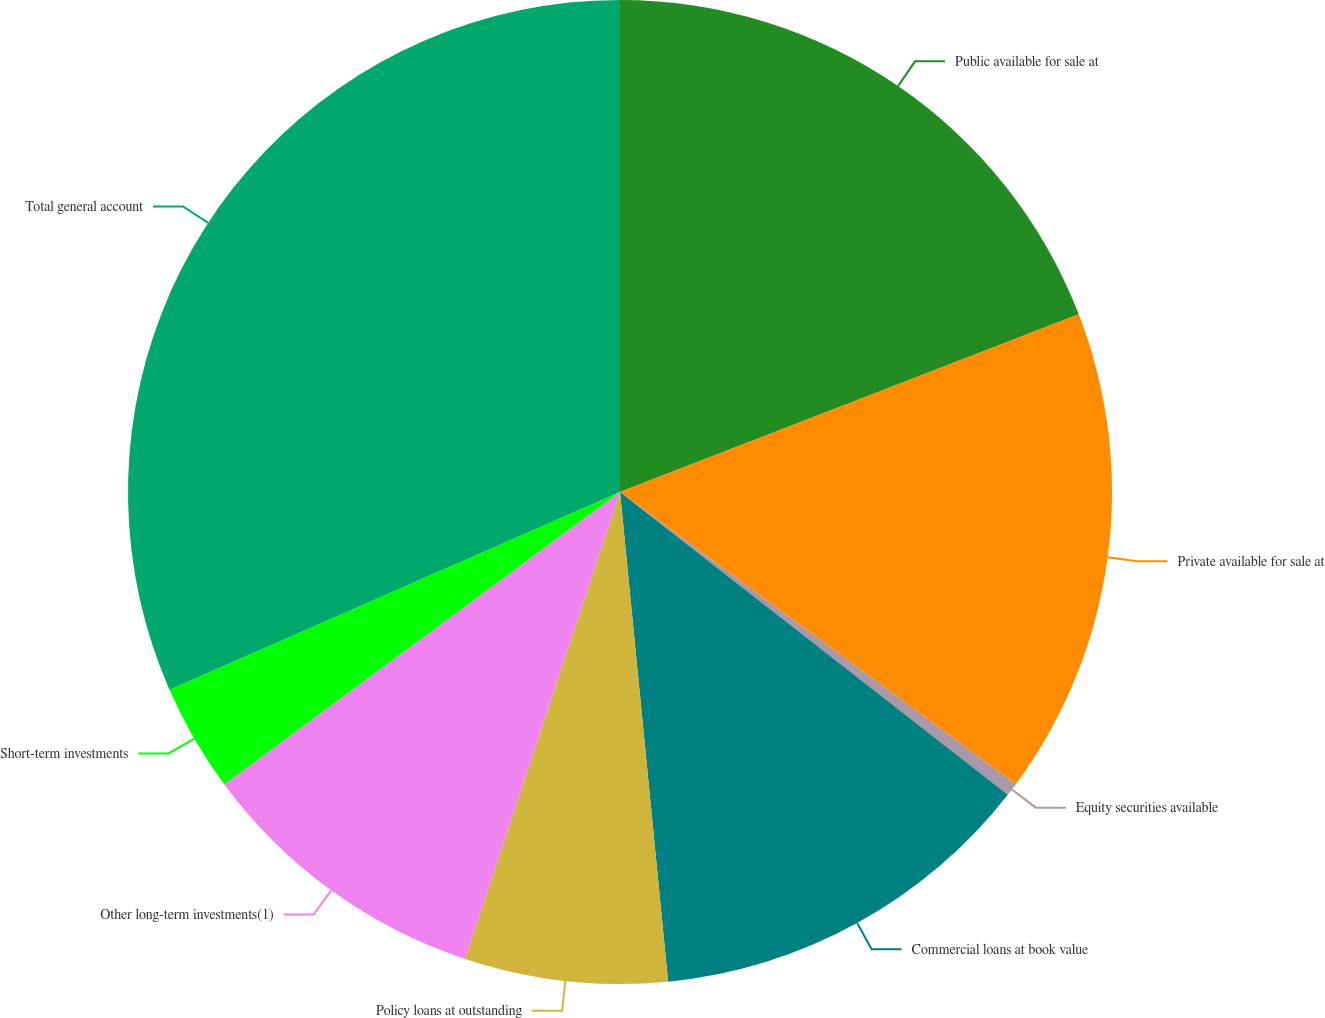<chart> <loc_0><loc_0><loc_500><loc_500><pie_chart><fcel>Public available for sale at<fcel>Private available for sale at<fcel>Equity securities available<fcel>Commercial loans at book value<fcel>Policy loans at outstanding<fcel>Other long-term investments(1)<fcel>Short-term investments<fcel>Total general account<nl><fcel>19.12%<fcel>16.0%<fcel>0.43%<fcel>12.89%<fcel>6.66%<fcel>9.77%<fcel>3.55%<fcel>31.58%<nl></chart> 